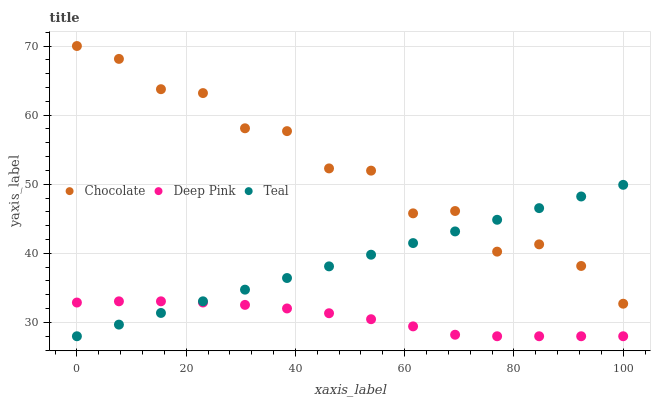Does Deep Pink have the minimum area under the curve?
Answer yes or no. Yes. Does Chocolate have the maximum area under the curve?
Answer yes or no. Yes. Does Teal have the minimum area under the curve?
Answer yes or no. No. Does Teal have the maximum area under the curve?
Answer yes or no. No. Is Teal the smoothest?
Answer yes or no. Yes. Is Chocolate the roughest?
Answer yes or no. Yes. Is Chocolate the smoothest?
Answer yes or no. No. Is Teal the roughest?
Answer yes or no. No. Does Deep Pink have the lowest value?
Answer yes or no. Yes. Does Chocolate have the lowest value?
Answer yes or no. No. Does Chocolate have the highest value?
Answer yes or no. Yes. Does Teal have the highest value?
Answer yes or no. No. Is Deep Pink less than Chocolate?
Answer yes or no. Yes. Is Chocolate greater than Deep Pink?
Answer yes or no. Yes. Does Teal intersect Chocolate?
Answer yes or no. Yes. Is Teal less than Chocolate?
Answer yes or no. No. Is Teal greater than Chocolate?
Answer yes or no. No. Does Deep Pink intersect Chocolate?
Answer yes or no. No. 